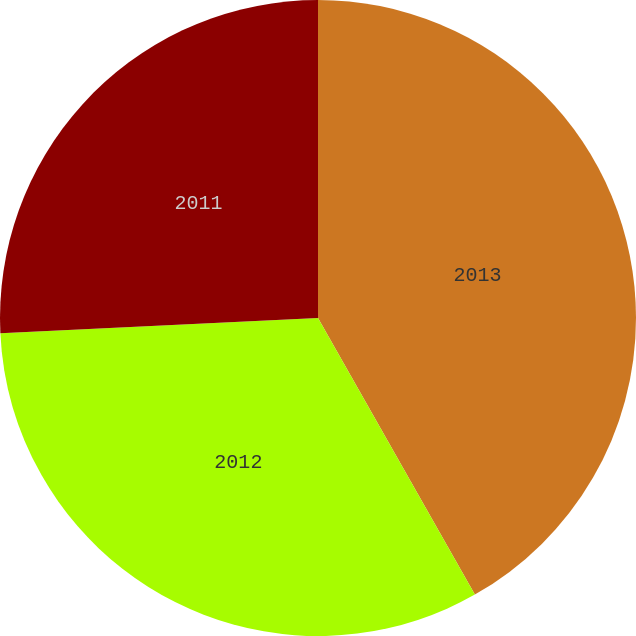Convert chart to OTSL. <chart><loc_0><loc_0><loc_500><loc_500><pie_chart><fcel>2013<fcel>2012<fcel>2011<nl><fcel>41.79%<fcel>32.45%<fcel>25.76%<nl></chart> 